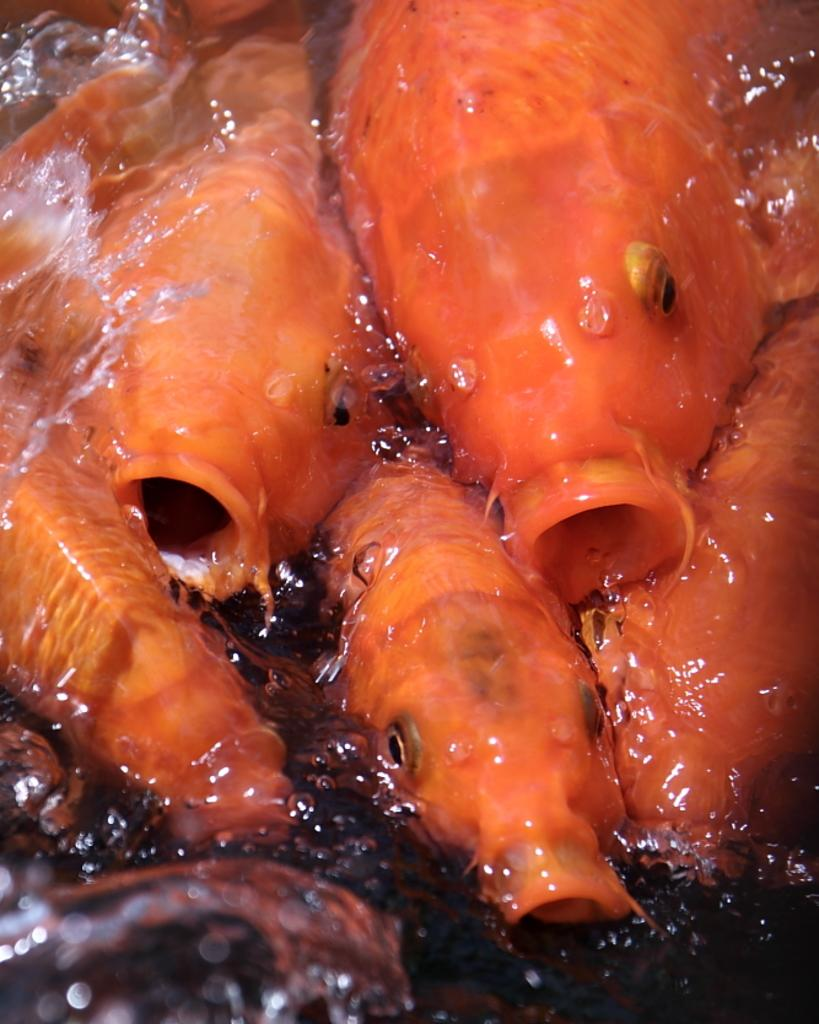What color are the fishes in the image? The fishes in the image are orange in color. Where are the fishes located in the image? The fishes are in water. What type of food is being served at the night event in the image? There is no night event or food present in the image; it features orange color fishes in water. What kind of truck can be seen transporting the fishes in the image? There is no truck present in the image; it only shows fishes in water. 